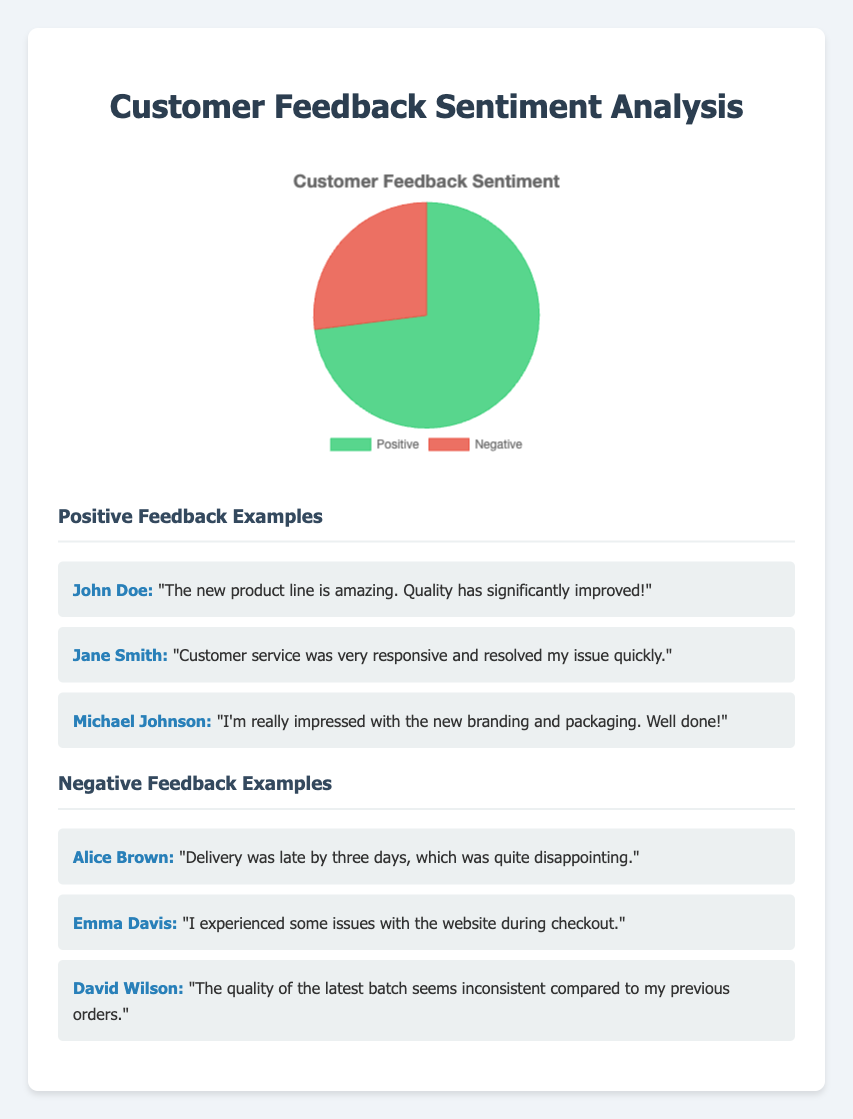What percentage of customers provided positive feedback? The chart shows two sections, one labeled "Positive" and one labeled "Negative". The data point for the "Positive" section indicates 73%.
Answer: 73% What is the difference in percentage between positive and negative feedback? The chart indicates that 73% is positive and 27% is negative. The difference is calculated by subtracting the smaller percentage from the larger one: 73% - 27% = 46%.
Answer: 46% What is the combined percentage of positive and negative feedback? Since the chart only shows two categories (Positive and Negative), their percentages should sum up to the whole data. Therefore, 73% (Positive) + 27% (Negative) = 100%.
Answer: 100% Which feedback category has a larger share? The chart visually splits the sentiment into two sections; the larger one is labeled "Positive" (73%) and the smaller one "Negative" (27%). Thus, the "Positive" category has the larger share.
Answer: Positive What is the ratio of positive to negative feedback? From the chart, Positive feedback is 73% and Negative feedback is 27%. To find the ratio, you divide the percentages: 73 / 27 ≈ 2.70. Thus, the ratio is approximately 2.70:1.
Answer: 2.70:1 What color represents the negative feedback in the chart? The chart uses colors to distinguish different categories. The "Negative" feedback section is in red.
Answer: Red How many times larger is the positive feedback compared to negative feedback? The chart shows Positive feedback at 73% and Negative at 27%. To find how many times larger Positive is, divide the Positive percentage by the Negative percentage: 73 / 27 ≈ 2.70. Positive feedback is approximately 2.70 times larger than Negative feedback.
Answer: 2.70 times What visual cue indicates the proportion of positive feedback? The chart uses a pie section to represent Positive feedback, which is both larger in size and labeled directly with the percentage (73%).
Answer: Larger pie section with 73% label If there were 100 feedback responses, how many were positive? The chart shows that 73% of feedback is positive. Therefore, if there were 100 responses, 0.73 * 100 = 73 responses would be positive.
Answer: 73 